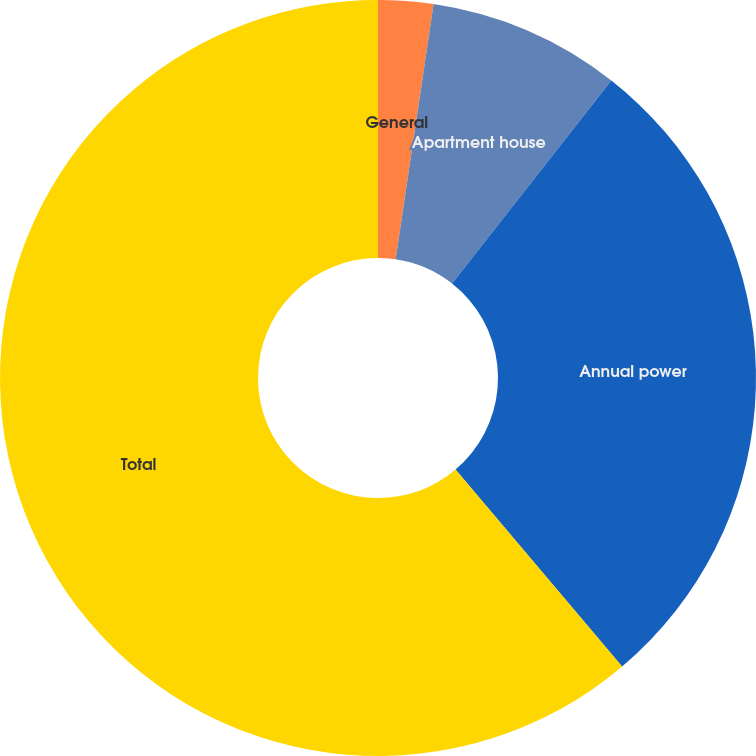Convert chart. <chart><loc_0><loc_0><loc_500><loc_500><pie_chart><fcel>General<fcel>Apartment house<fcel>Annual power<fcel>Total<nl><fcel>2.35%<fcel>8.24%<fcel>28.24%<fcel>61.18%<nl></chart> 